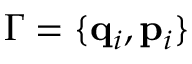Convert formula to latex. <formula><loc_0><loc_0><loc_500><loc_500>\Gamma = \{ q _ { i } , p _ { i } \}</formula> 